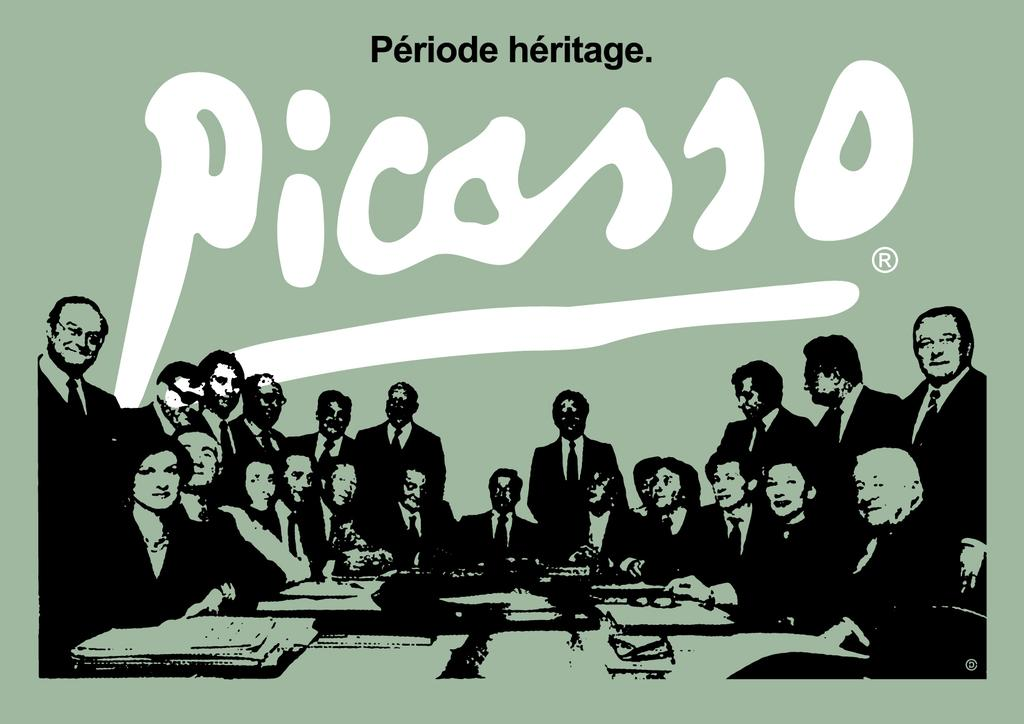What is present in the image that contains information or a message? There is a poster in the image that contains information or a message. What can be found on the poster besides the image of several persons? The poster contains text and an image of several objects. How many chairs are depicted on the poster? There is no mention of chairs in the image or the provided facts, so it cannot be determined from the information given. 